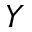<formula> <loc_0><loc_0><loc_500><loc_500>Y</formula> 